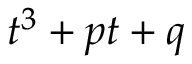<formula> <loc_0><loc_0><loc_500><loc_500>t ^ { 3 } + p t + q</formula> 